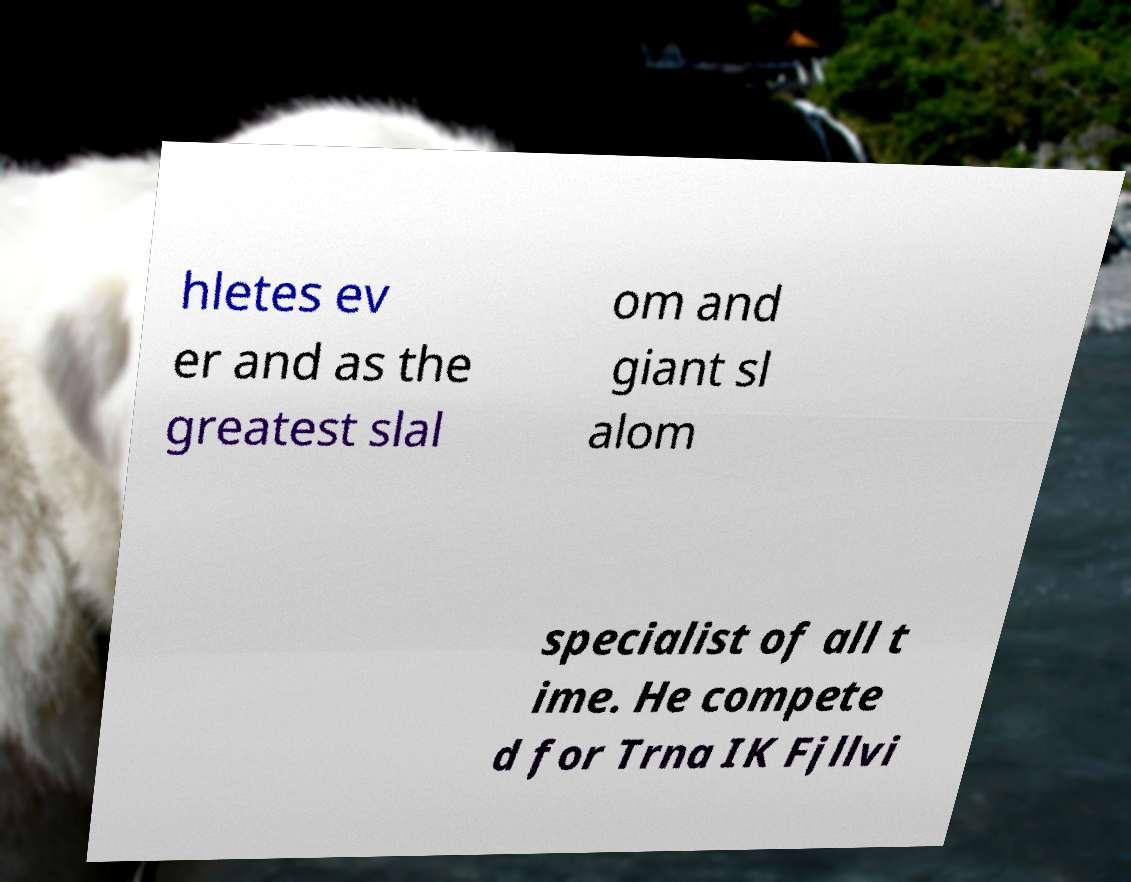What messages or text are displayed in this image? I need them in a readable, typed format. hletes ev er and as the greatest slal om and giant sl alom specialist of all t ime. He compete d for Trna IK Fjllvi 